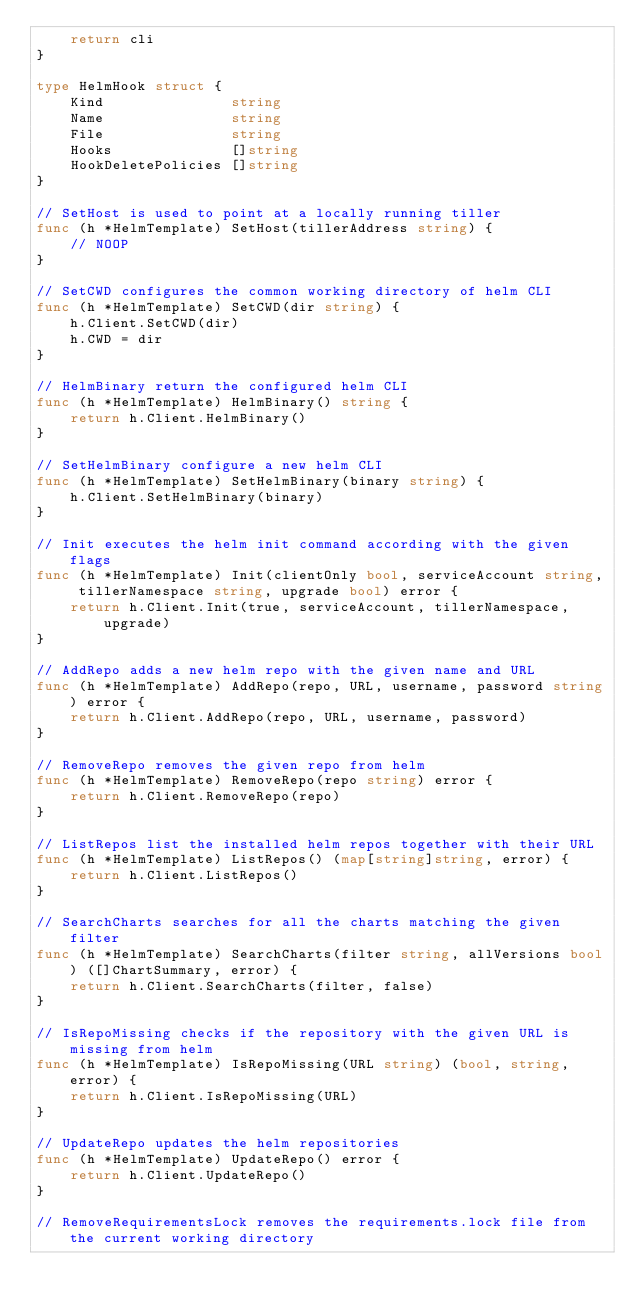Convert code to text. <code><loc_0><loc_0><loc_500><loc_500><_Go_>	return cli
}

type HelmHook struct {
	Kind               string
	Name               string
	File               string
	Hooks              []string
	HookDeletePolicies []string
}

// SetHost is used to point at a locally running tiller
func (h *HelmTemplate) SetHost(tillerAddress string) {
	// NOOP
}

// SetCWD configures the common working directory of helm CLI
func (h *HelmTemplate) SetCWD(dir string) {
	h.Client.SetCWD(dir)
	h.CWD = dir
}

// HelmBinary return the configured helm CLI
func (h *HelmTemplate) HelmBinary() string {
	return h.Client.HelmBinary()
}

// SetHelmBinary configure a new helm CLI
func (h *HelmTemplate) SetHelmBinary(binary string) {
	h.Client.SetHelmBinary(binary)
}

// Init executes the helm init command according with the given flags
func (h *HelmTemplate) Init(clientOnly bool, serviceAccount string, tillerNamespace string, upgrade bool) error {
	return h.Client.Init(true, serviceAccount, tillerNamespace, upgrade)
}

// AddRepo adds a new helm repo with the given name and URL
func (h *HelmTemplate) AddRepo(repo, URL, username, password string) error {
	return h.Client.AddRepo(repo, URL, username, password)
}

// RemoveRepo removes the given repo from helm
func (h *HelmTemplate) RemoveRepo(repo string) error {
	return h.Client.RemoveRepo(repo)
}

// ListRepos list the installed helm repos together with their URL
func (h *HelmTemplate) ListRepos() (map[string]string, error) {
	return h.Client.ListRepos()
}

// SearchCharts searches for all the charts matching the given filter
func (h *HelmTemplate) SearchCharts(filter string, allVersions bool) ([]ChartSummary, error) {
	return h.Client.SearchCharts(filter, false)
}

// IsRepoMissing checks if the repository with the given URL is missing from helm
func (h *HelmTemplate) IsRepoMissing(URL string) (bool, string, error) {
	return h.Client.IsRepoMissing(URL)
}

// UpdateRepo updates the helm repositories
func (h *HelmTemplate) UpdateRepo() error {
	return h.Client.UpdateRepo()
}

// RemoveRequirementsLock removes the requirements.lock file from the current working directory</code> 